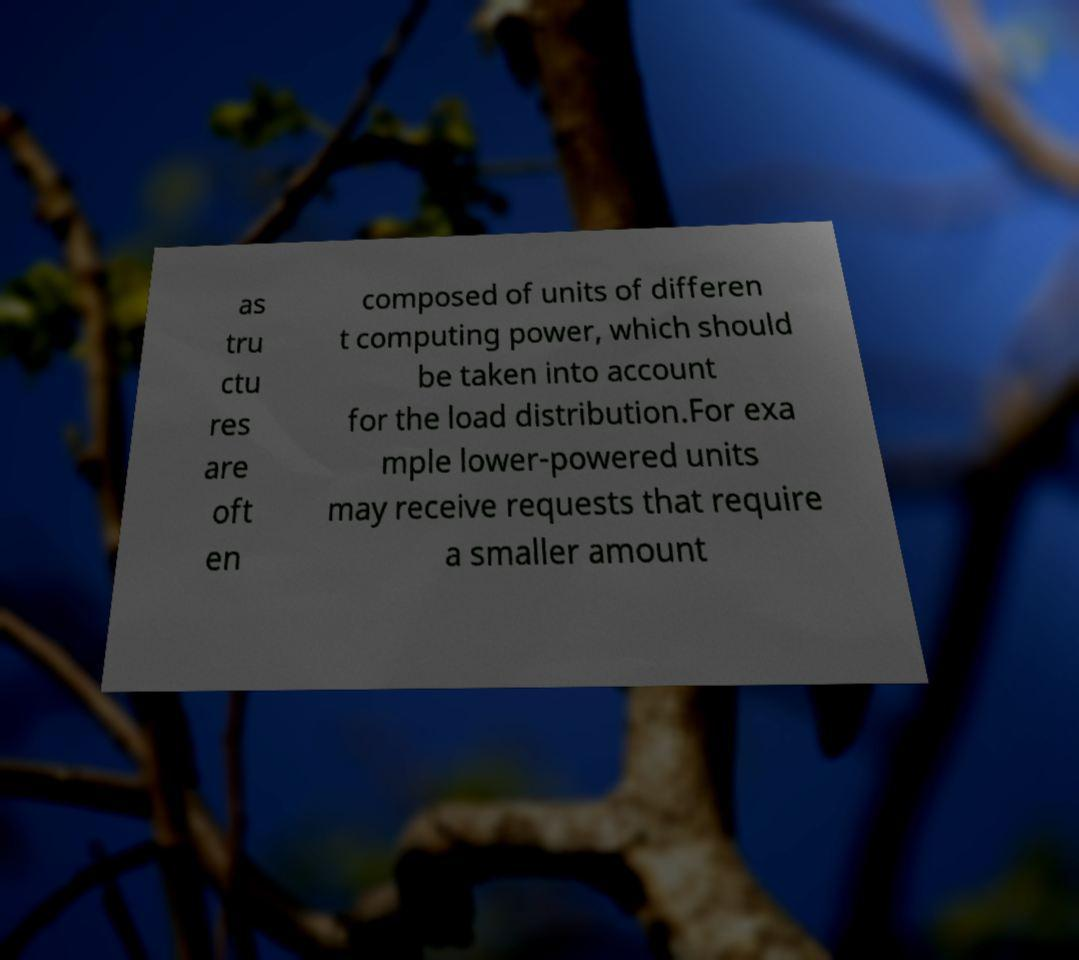Can you accurately transcribe the text from the provided image for me? as tru ctu res are oft en composed of units of differen t computing power, which should be taken into account for the load distribution.For exa mple lower-powered units may receive requests that require a smaller amount 